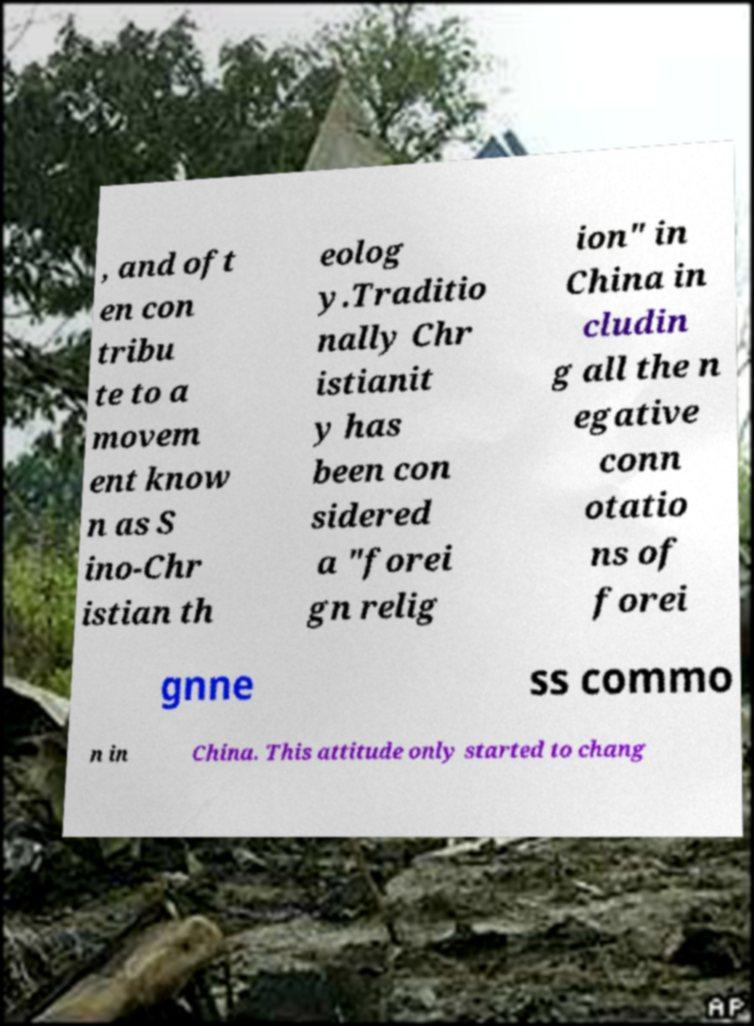Please read and relay the text visible in this image. What does it say? , and oft en con tribu te to a movem ent know n as S ino-Chr istian th eolog y.Traditio nally Chr istianit y has been con sidered a "forei gn relig ion" in China in cludin g all the n egative conn otatio ns of forei gnne ss commo n in China. This attitude only started to chang 